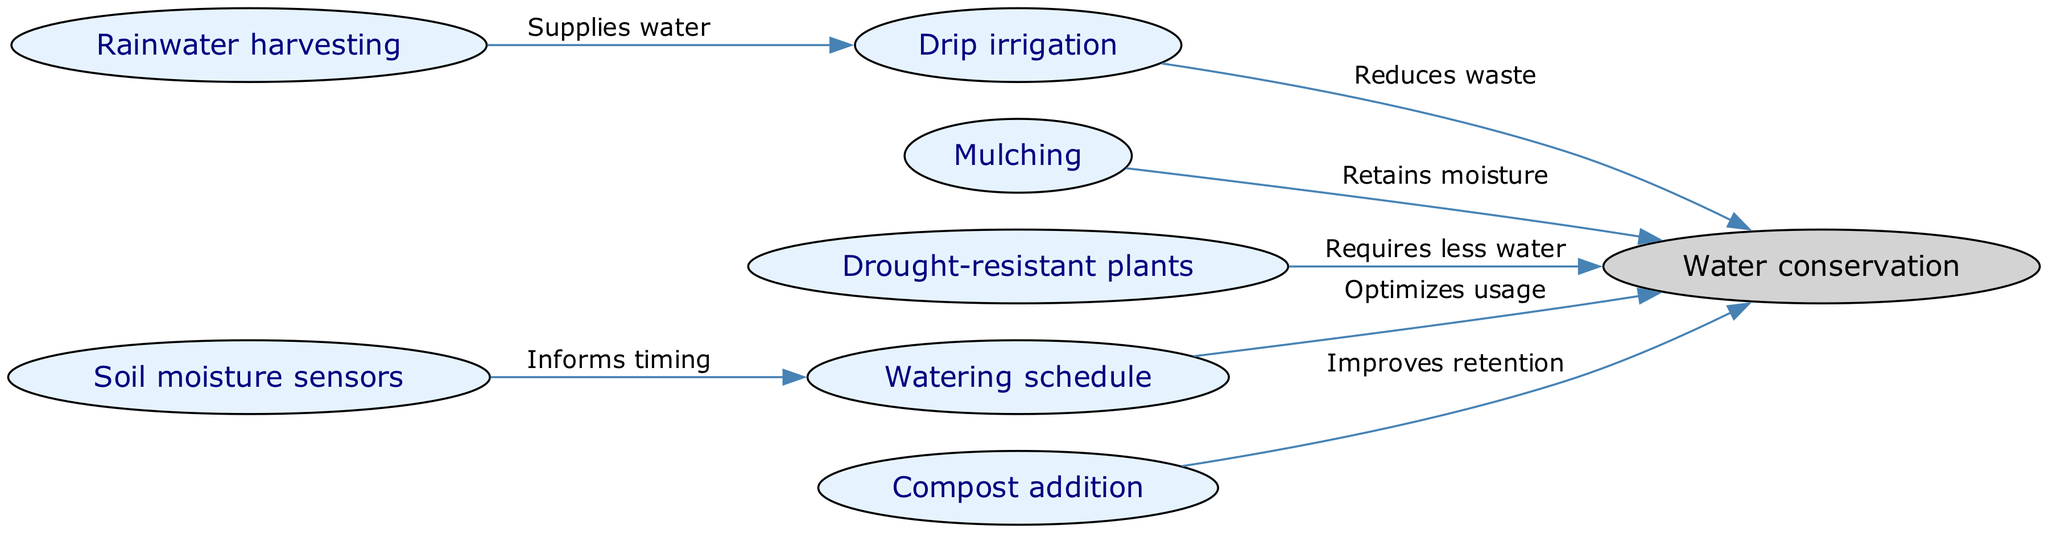What is one technique that supplies water for irrigation? The diagram shows "Rainwater harvesting" as a node that has a directed edge pointing to "Drip irrigation" with the label "Supplies water." Therefore, it is the technique that supplies water.
Answer: Rainwater harvesting How many nodes are present in the diagram? The diagram has a total of 7 nodes listed in the "nodes" section. These nodes include "Rainwater harvesting," "Drip irrigation," "Mulching," "Drought-resistant plants," "Watering schedule," "Soil moisture sensors," and "Compost addition."
Answer: 7 What does the "Mulching" technique contribute to? "Mulching" has a directed edge pointing to "Water conservation" with the label "Retains moisture," indicating that its contribution is to water conservation.
Answer: Water conservation Which technique relies on soil moisture sensors to optimize usage? The "Watering schedule" node receives its information from "Soil moisture sensors," as indicated by the directed edge pointing from "Soil moisture sensors" to "Watering schedule" with the label "Informs timing." Therefore, the technique that relies on moisture sensors for optimization is "Watering schedule."
Answer: Watering schedule How does "Compost addition" help with water conservation? The edge from "Compost addition" to "Water conservation" is labeled "Improves retention," showing that compost helps retain water, contributing to water conservation.
Answer: Improves retention Which two techniques directly contribute to water conservation in the diagram? The directed edges leading to "Water conservation" show that "Mulching" and "Drought-resistant plants" both have direct contributions to water conservation as they both point to it. Hence, the two techniques are "Mulching" and "Drought-resistant plants."
Answer: Mulching, Drought-resistant plants 